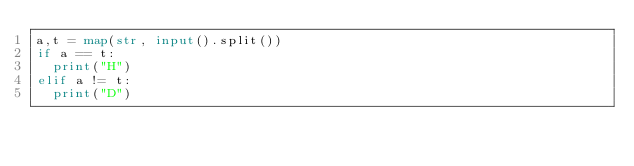<code> <loc_0><loc_0><loc_500><loc_500><_Python_>a,t = map(str, input().split())
if a == t:
  print("H")
elif a != t:
  print("D")
  </code> 